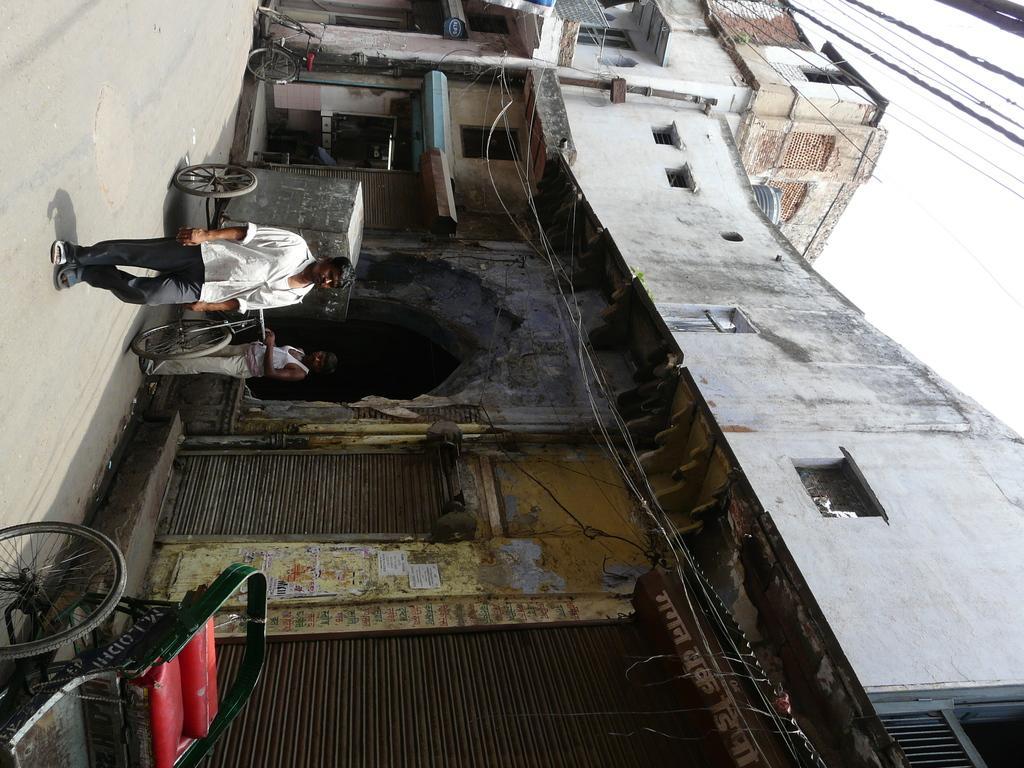Could you give a brief overview of what you see in this image? In this image I can see two people are on the road. In-front of one person I can see the bicycle. To the side I can see the building and the shutters. And there is a wheelchair on the road. In the back I can see the wires and the white sky. 